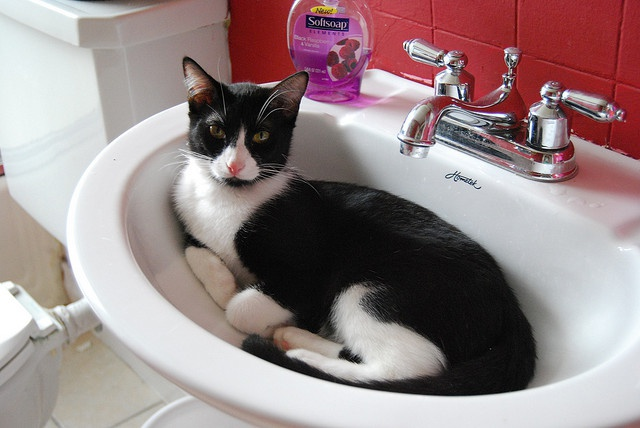Describe the objects in this image and their specific colors. I can see sink in white, lightgray, black, darkgray, and gray tones, cat in white, black, darkgray, lightgray, and gray tones, and toilet in white, lightgray, darkgray, and gray tones in this image. 